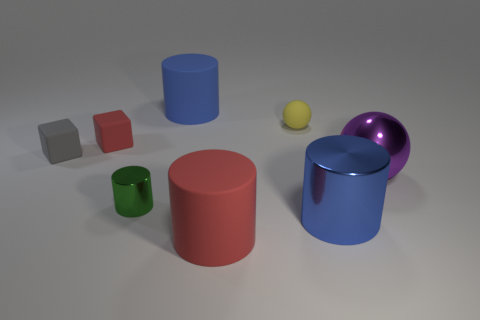Add 2 small brown shiny balls. How many objects exist? 10 Subtract all tiny green cylinders. How many cylinders are left? 3 Subtract 2 cubes. How many cubes are left? 0 Subtract all purple spheres. How many spheres are left? 1 Subtract all tiny red blocks. Subtract all tiny gray rubber things. How many objects are left? 6 Add 1 large blue rubber objects. How many large blue rubber objects are left? 2 Add 3 brown balls. How many brown balls exist? 3 Subtract 2 blue cylinders. How many objects are left? 6 Subtract all balls. How many objects are left? 6 Subtract all green cylinders. Subtract all purple blocks. How many cylinders are left? 3 